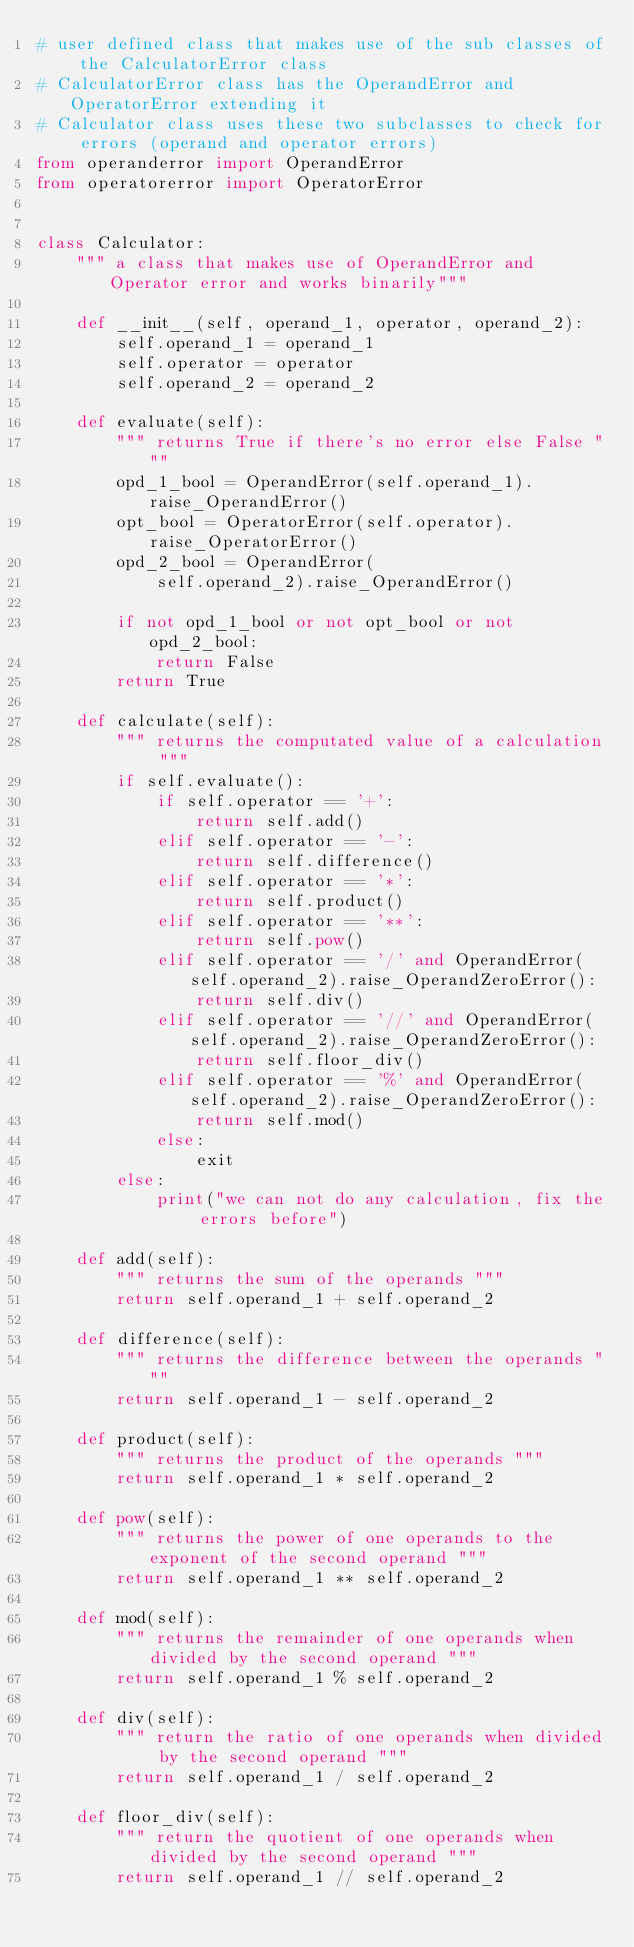Convert code to text. <code><loc_0><loc_0><loc_500><loc_500><_Python_># user defined class that makes use of the sub classes of the CalculatorError class
# CalculatorError class has the OperandError and OperatorError extending it
# Calculator class uses these two subclasses to check for errors (operand and operator errors)
from operanderror import OperandError
from operatorerror import OperatorError


class Calculator:
    """ a class that makes use of OperandError and Operator error and works binarily"""

    def __init__(self, operand_1, operator, operand_2):
        self.operand_1 = operand_1
        self.operator = operator
        self.operand_2 = operand_2

    def evaluate(self):
        """ returns True if there's no error else False """
        opd_1_bool = OperandError(self.operand_1).raise_OperandError()
        opt_bool = OperatorError(self.operator).raise_OperatorError()
        opd_2_bool = OperandError(
            self.operand_2).raise_OperandError()

        if not opd_1_bool or not opt_bool or not opd_2_bool:
            return False
        return True

    def calculate(self):
        """ returns the computated value of a calculation """
        if self.evaluate():
            if self.operator == '+':
                return self.add()
            elif self.operator == '-':
                return self.difference()
            elif self.operator == '*':
                return self.product()
            elif self.operator == '**':
                return self.pow()
            elif self.operator == '/' and OperandError(self.operand_2).raise_OperandZeroError():
                return self.div()
            elif self.operator == '//' and OperandError(self.operand_2).raise_OperandZeroError():
                return self.floor_div()
            elif self.operator == '%' and OperandError(self.operand_2).raise_OperandZeroError():
                return self.mod()
            else:
                exit
        else:
            print("we can not do any calculation, fix the errors before")

    def add(self):
        """ returns the sum of the operands """
        return self.operand_1 + self.operand_2

    def difference(self):
        """ returns the difference between the operands """
        return self.operand_1 - self.operand_2

    def product(self):
        """ returns the product of the operands """
        return self.operand_1 * self.operand_2

    def pow(self):
        """ returns the power of one operands to the exponent of the second operand """
        return self.operand_1 ** self.operand_2

    def mod(self):
        """ returns the remainder of one operands when divided by the second operand """
        return self.operand_1 % self.operand_2

    def div(self):
        """ return the ratio of one operands when divided by the second operand """
        return self.operand_1 / self.operand_2

    def floor_div(self):
        """ return the quotient of one operands when divided by the second operand """
        return self.operand_1 // self.operand_2
</code> 